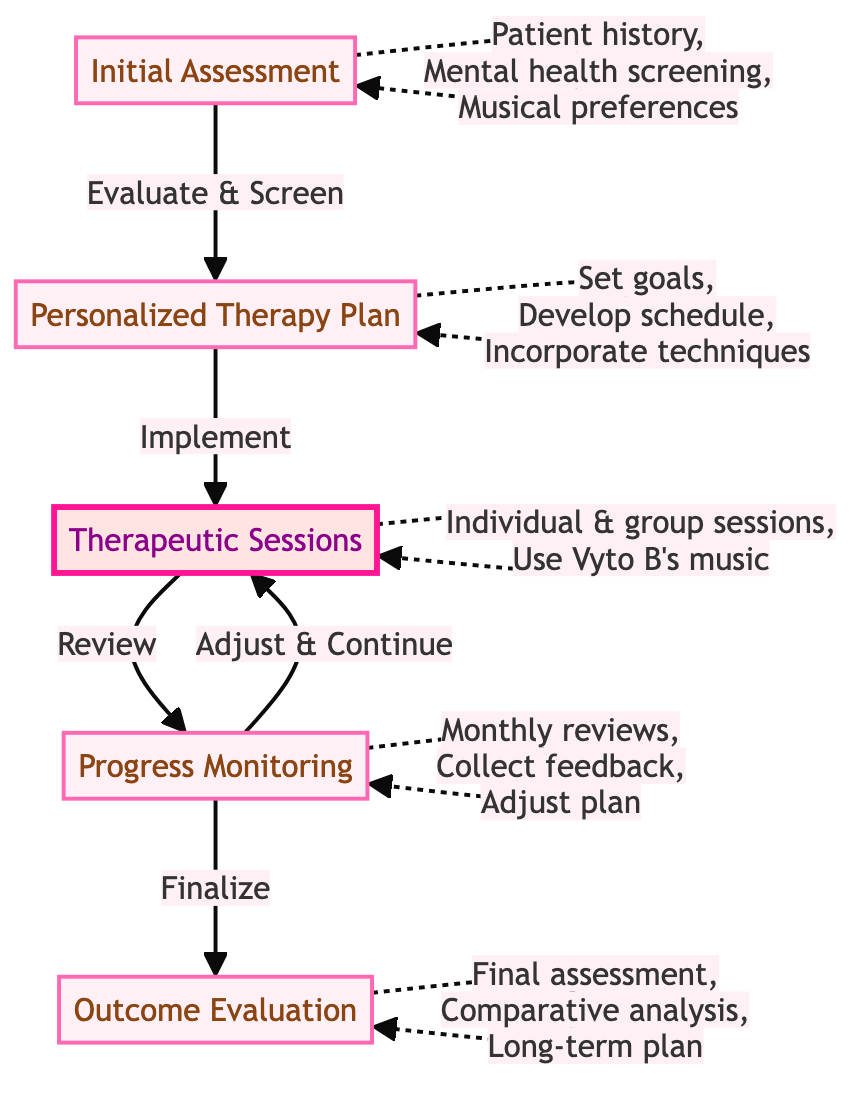What's the first step in the clinical pathway? The first step is labeled as "Initial Assessment," which is clearly indicated at the start of the diagram.
Answer: Initial Assessment How many main steps are there in the clinical pathway? By counting the main nodes represented in the flowchart, there are a total of five steps defined in the pathway.
Answer: 5 What activities are involved in the "Therapeutic Sessions"? The activities listed for the "Therapeutic Sessions" include weekly individual sessions, group music therapy, and in-session activities using Vyto B's music.
Answer: Weekly individual sessions, group music therapy, in-session activities using Vyto B's music Which step follows "Progress Monitoring"? Referring to the flow direction indicated by arrows in the diagram, the step that follows "Progress Monitoring" is "Outcome Evaluation."
Answer: Outcome Evaluation How often are progress reviews conducted during the process? The diagram specifies that progress reviews are conducted on a monthly basis, as explicitly indicated under the "Progress Monitoring" step.
Answer: Monthly What is included in the activities of the "Personalized Therapy Plan"? The activities involve setting goals, developing a music therapy schedule, and incorporating relaxation techniques, which are all clearly listed in the relevant node.
Answer: Set goals, develop a music therapy schedule, incorporate relaxation techniques What is the purpose of the "Outcome Evaluation" step? The final step's purpose is to conduct a final mental health assessment, compare initial and final states, and develop a long-term maintenance plan, as stated in the associated activities.
Answer: Final mental health assessment, comparative analysis, develop a long-term maintenance plan What is used during in-session activities to regulate mood? According to the diagram, Wyto B's music is specifically mentioned to be used for mood regulation and anxiety reduction in the therapeutic sessions.
Answer: Vyto B's music What happens after collecting patient feedback? Based on the flow indicated in the diagram, after collecting patient feedback, the therapy plan is adjusted accordingly, ensuring the inclusion of effective music tracks.
Answer: Adjustment of therapy plan 